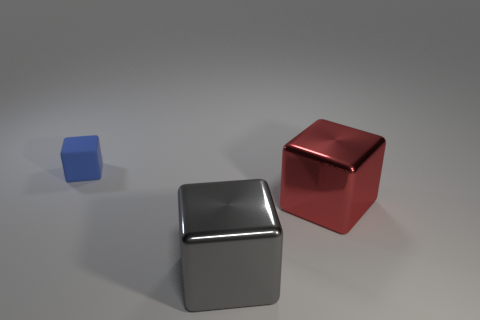Could you describe the lighting in this scene? The lighting in the scene appears to be soft and diffused, with subtle shadows cast by the cubes, indicating a light source that is not extremely harsh or direct. This kind of lighting creates a gentle contrast on the objects, highlighting their geometric shapes without producing sharp, high-contrast shadows.  What kind of mood or atmosphere does the lighting contribute to? The soft and diffused lighting contributes to a calm, peaceful, and somewhat neutral atmosphere. There are no dramatic shadows or high contrasts, which often evoke a more dynamic or tense mood. Instead, the subtle shading and gentle light gradients offer a sense of tranquility and simplicity. 